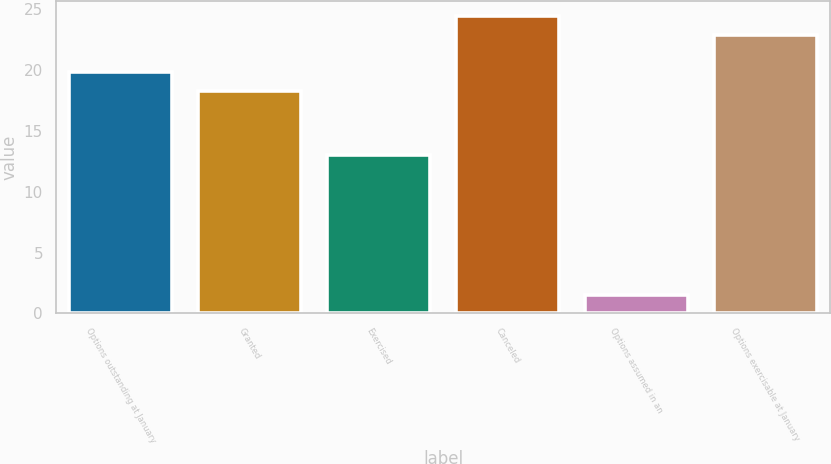Convert chart to OTSL. <chart><loc_0><loc_0><loc_500><loc_500><bar_chart><fcel>Options outstanding at January<fcel>Granted<fcel>Exercised<fcel>Canceled<fcel>Options assumed in an<fcel>Options exercisable at January<nl><fcel>19.86<fcel>18.32<fcel>13.05<fcel>24.48<fcel>1.51<fcel>22.94<nl></chart> 